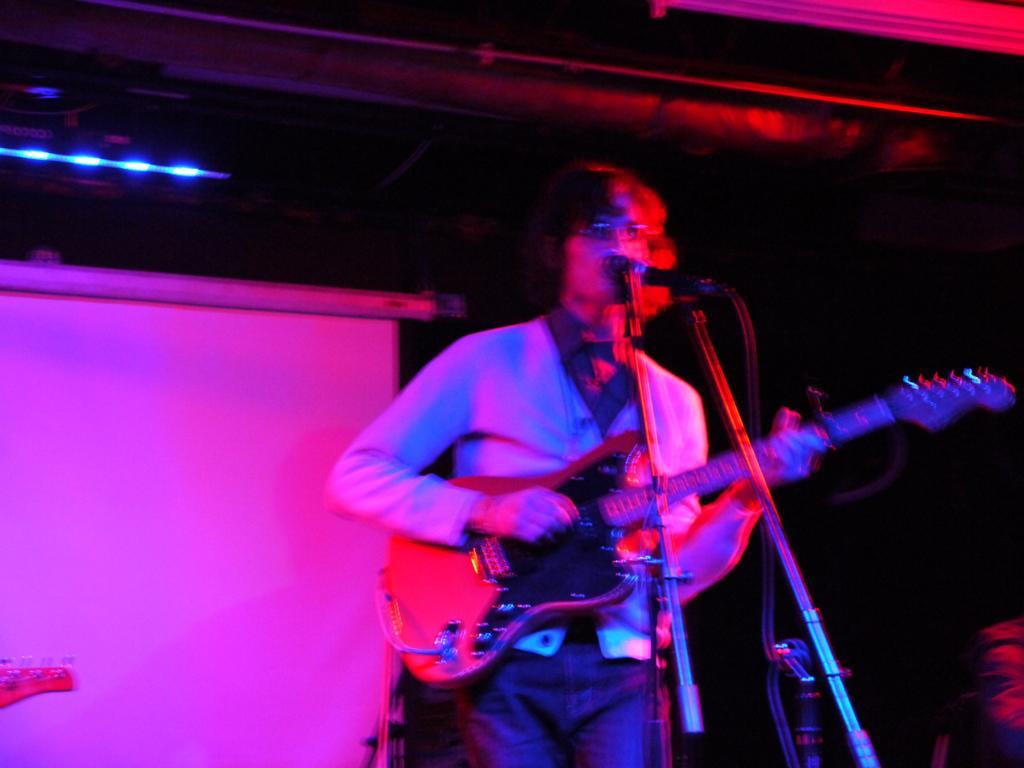What is the man in the image doing? The man is playing the guitar and singing on a microphone. What instrument is the man holding in the image? The man is holding a guitar in the image. What can be seen in the background of the image? There is a screen and light in the background, and the background is dark. Can you see the man's friend playing the whistle in the image? There is no friend or whistle present in the image. 